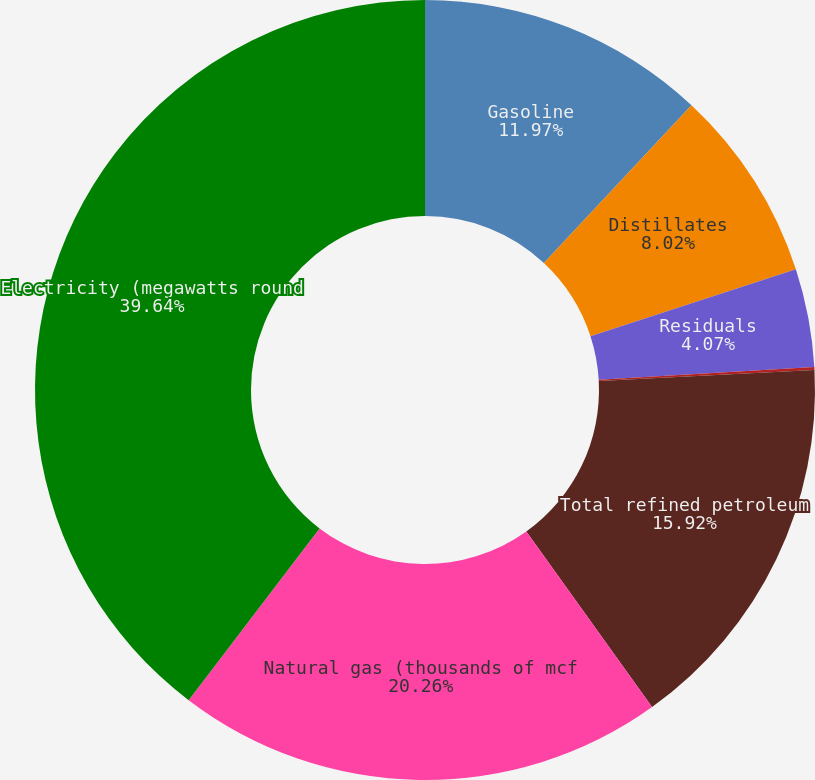Convert chart to OTSL. <chart><loc_0><loc_0><loc_500><loc_500><pie_chart><fcel>Gasoline<fcel>Distillates<fcel>Residuals<fcel>Other<fcel>Total refined petroleum<fcel>Natural gas (thousands of mcf<fcel>Electricity (megawatts round<nl><fcel>11.97%<fcel>8.02%<fcel>4.07%<fcel>0.12%<fcel>15.92%<fcel>20.25%<fcel>39.63%<nl></chart> 